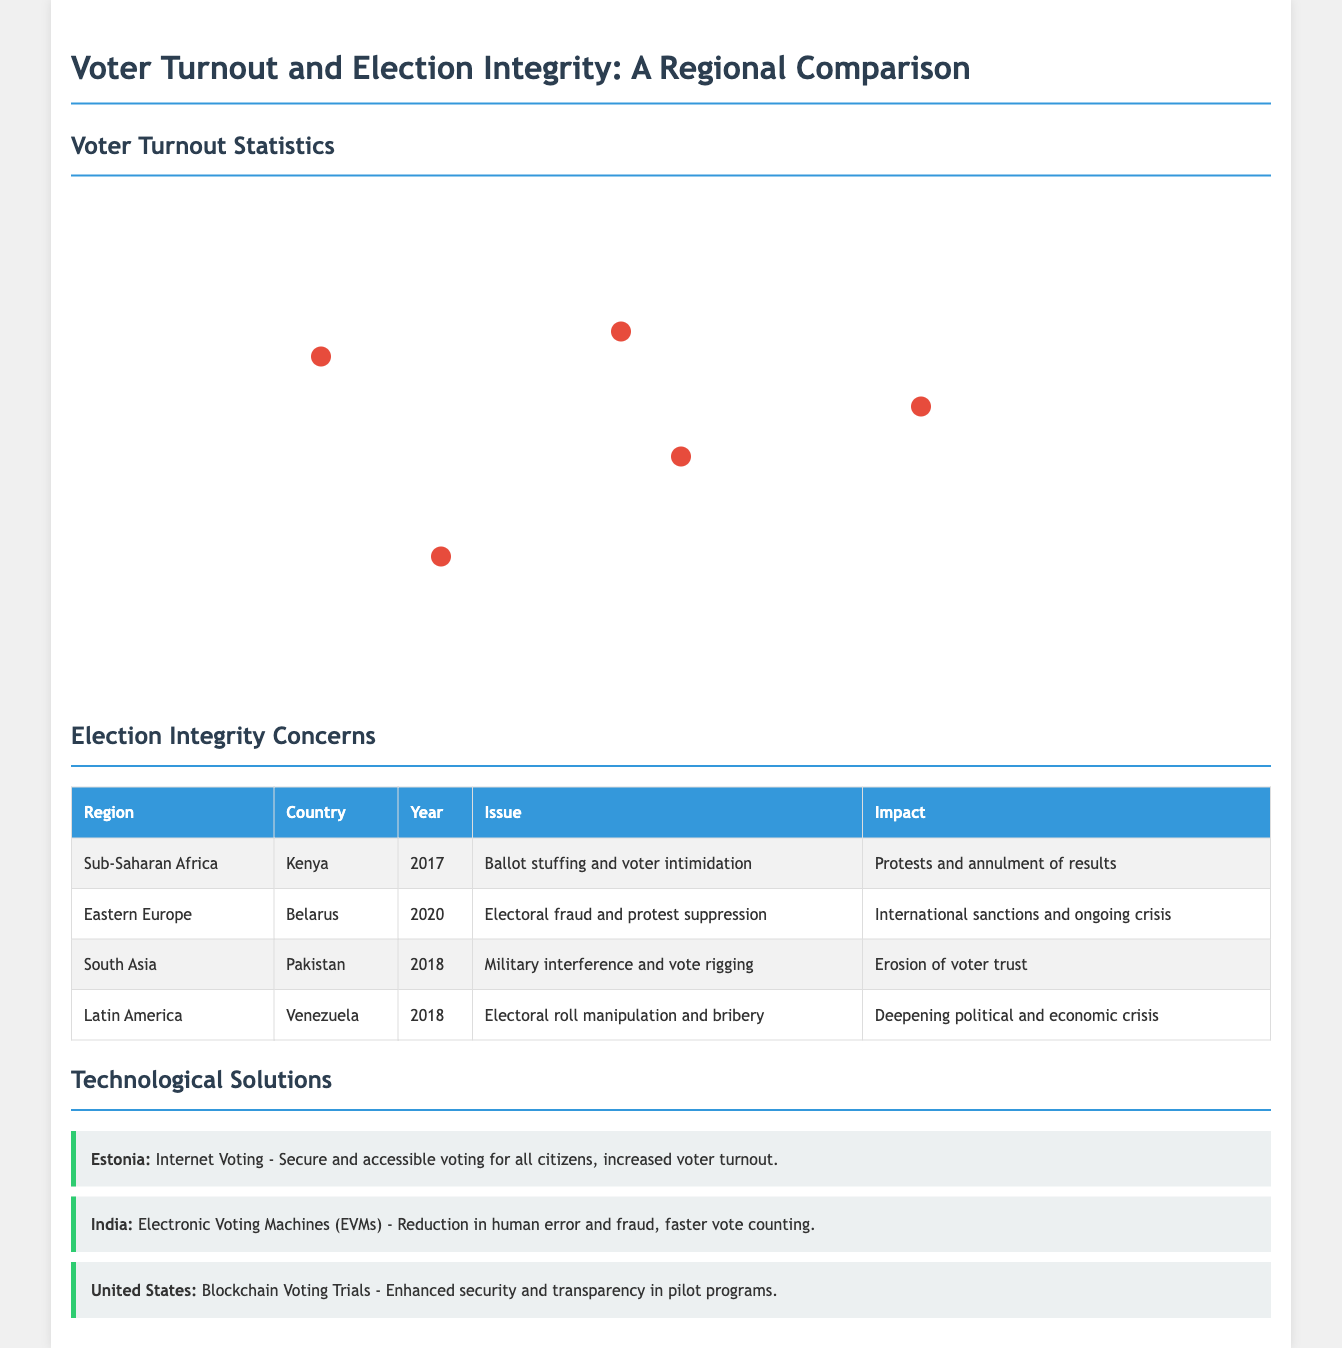What was the voter turnout in the United States in 2020? The document states that the voter turnout in the United States in 2020 was 66.8%.
Answer: 66.8% What issue was reported in Kenya during the 2017 election? According to the table, the issue reported in Kenya during the 2017 election was ballot stuffing and voter intimidation.
Answer: Ballot stuffing and voter intimidation What is the voter turnout percentage for Brazil in 2018? The document indicates that the voter turnout percentage for Brazil in 2018 was 78.7%.
Answer: 78.7% Which country faced electoral fraud and protest suppression in 2020? The document mentions that Belarus faced electoral fraud and protest suppression in 2020.
Answer: Belarus What technological solution was implemented in Estonia? The document describes that Estonia implemented internet voting as a technological solution.
Answer: Internet Voting Which region reported a deepening political and economic crisis due to electoral roll manipulation? The document shows that Latin America reported a deepening political and economic crisis due to electoral roll manipulation.
Answer: Latin America What was the turnout percentage for Nigeria in 2019? The document states that the turnout percentage for Nigeria in 2019 was 34.75%.
Answer: 34.75% Which country utilized Electronic Voting Machines to reduce human error? The document states that India utilized Electronic Voting Machines to reduce human error.
Answer: India What was the notable change in voter turnout in the United States during the COVID-19 pandemic? The document states there was a notable increase in voter turnout due to mail-in voting during COVID-19.
Answer: Increase due to mail-in voting 